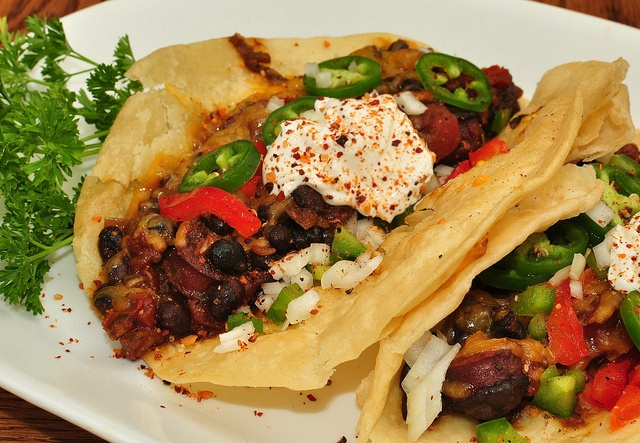Describe the objects in this image and their specific colors. I can see various objects in this image with different colors. 